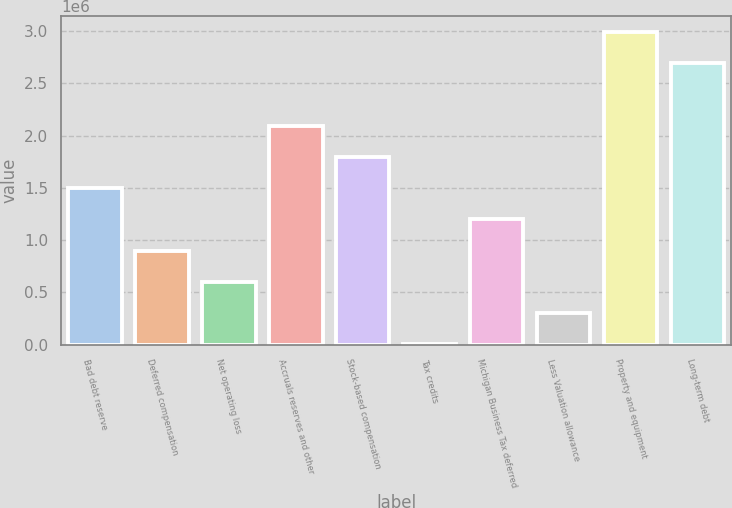Convert chart. <chart><loc_0><loc_0><loc_500><loc_500><bar_chart><fcel>Bad debt reserve<fcel>Deferred compensation<fcel>Net operating loss<fcel>Accruals reserves and other<fcel>Stock-based compensation<fcel>Tax credits<fcel>Michigan Business Tax deferred<fcel>Less Valuation allowance<fcel>Property and equipment<fcel>Long-term debt<nl><fcel>1.49765e+06<fcel>899588<fcel>600556<fcel>2.09572e+06<fcel>1.79669e+06<fcel>2491<fcel>1.19862e+06<fcel>301524<fcel>2.99282e+06<fcel>2.69378e+06<nl></chart> 